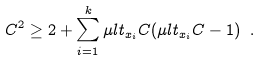Convert formula to latex. <formula><loc_0><loc_0><loc_500><loc_500>C ^ { 2 } \geq 2 + \sum _ { i = 1 } ^ { k } \mu l t _ { x _ { i } } C ( \mu l t _ { x _ { i } } C - 1 ) \ .</formula> 